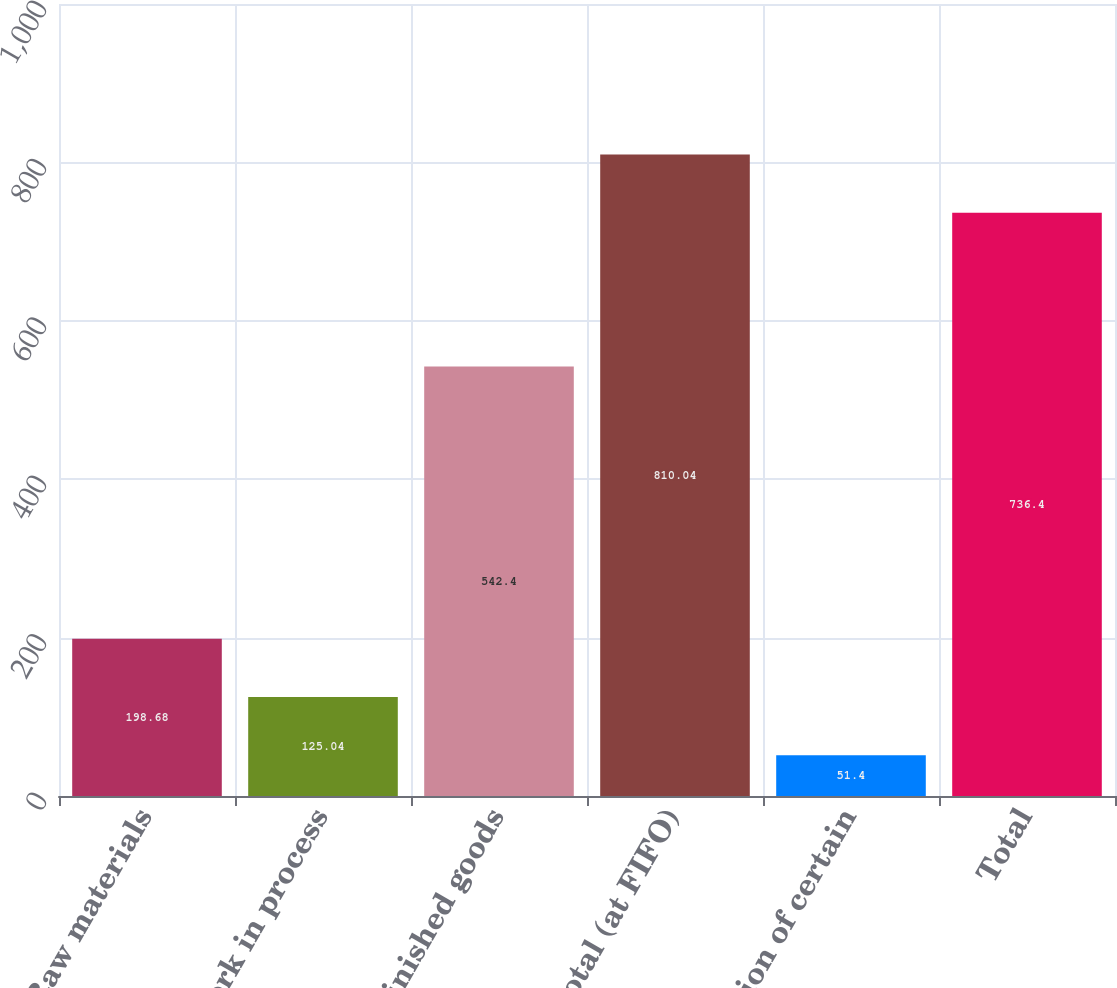<chart> <loc_0><loc_0><loc_500><loc_500><bar_chart><fcel>Raw materials<fcel>Work in process<fcel>Finished goods<fcel>Subtotal (at FIFO)<fcel>Reduction of certain<fcel>Total<nl><fcel>198.68<fcel>125.04<fcel>542.4<fcel>810.04<fcel>51.4<fcel>736.4<nl></chart> 